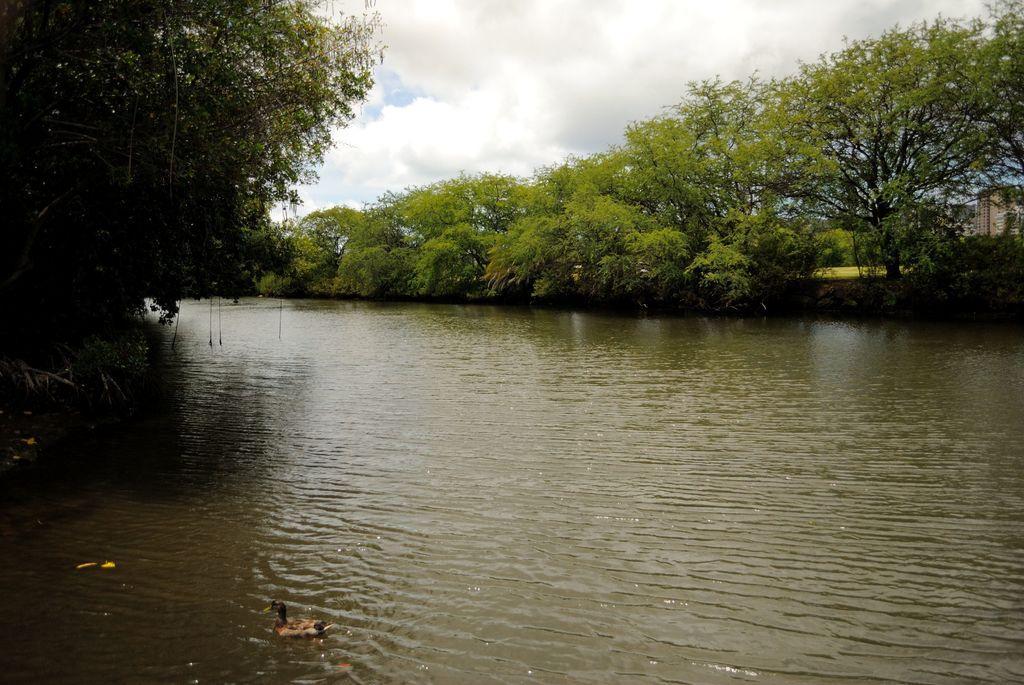Describe this image in one or two sentences. In the center of the image we can see trees, building, grass. At the bottom of the image we can see a duck. In the background of the image we can see the water. At the top of the image we can see the clouds are present in the sky. 